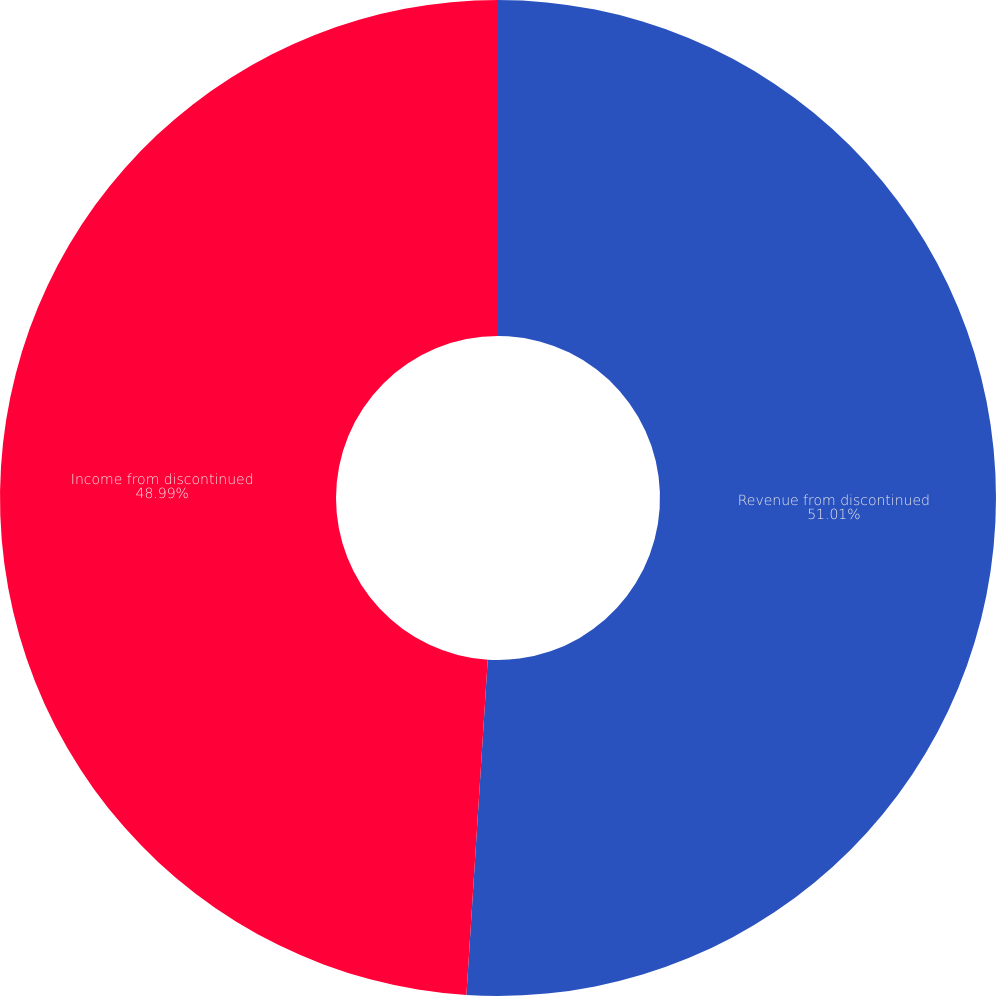Convert chart. <chart><loc_0><loc_0><loc_500><loc_500><pie_chart><fcel>Revenue from discontinued<fcel>Income from discontinued<nl><fcel>51.01%<fcel>48.99%<nl></chart> 